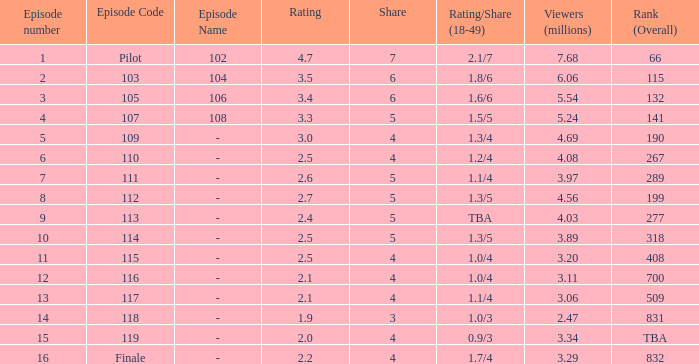WHAT IS THE RATING THAT HAD A SHARE SMALLER THAN 4, AND 2.47 MILLION VIEWERS? 0.0. Would you mind parsing the complete table? {'header': ['Episode number', 'Episode Code', 'Episode Name', 'Rating', 'Share', 'Rating/Share (18-49)', 'Viewers (millions)', 'Rank (Overall)'], 'rows': [['1', 'Pilot', '102', '4.7', '7', '2.1/7', '7.68', '66'], ['2', '103', '104', '3.5', '6', '1.8/6', '6.06', '115'], ['3', '105', '106', '3.4', '6', '1.6/6', '5.54', '132'], ['4', '107', '108', '3.3', '5', '1.5/5', '5.24', '141'], ['5', '109', '-', '3.0', '4', '1.3/4', '4.69', '190'], ['6', '110', '-', '2.5', '4', '1.2/4', '4.08', '267'], ['7', '111', '-', '2.6', '5', '1.1/4', '3.97', '289'], ['8', '112', '-', '2.7', '5', '1.3/5', '4.56', '199'], ['9', '113', '-', '2.4', '5', 'TBA', '4.03', '277'], ['10', '114', '-', '2.5', '5', '1.3/5', '3.89', '318'], ['11', '115', '-', '2.5', '4', '1.0/4', '3.20', '408'], ['12', '116', '-', '2.1', '4', '1.0/4', '3.11', '700'], ['13', '117', '-', '2.1', '4', '1.1/4', '3.06', '509'], ['14', '118', '-', '1.9', '3', '1.0/3', '2.47', '831'], ['15', '119', '-', '2.0', '4', '0.9/3', '3.34', 'TBA'], ['16', 'Finale', '-', '2.2', '4', '1.7/4', '3.29', '832']]} 